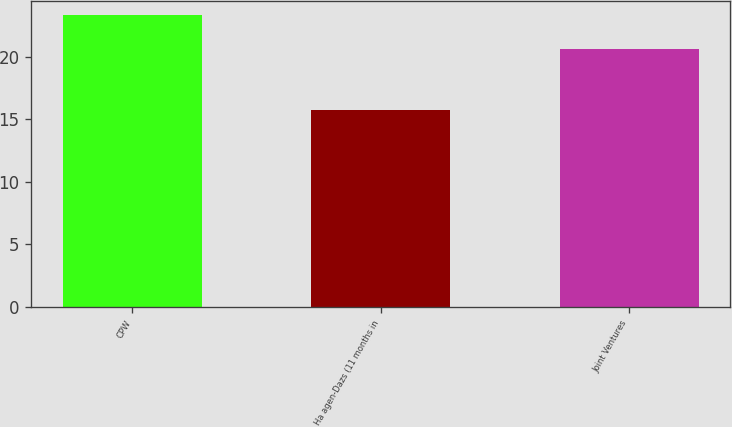<chart> <loc_0><loc_0><loc_500><loc_500><bar_chart><fcel>CPW<fcel>Ha agen-Dazs (11 months in<fcel>Joint Ventures<nl><fcel>23.3<fcel>15.7<fcel>20.6<nl></chart> 